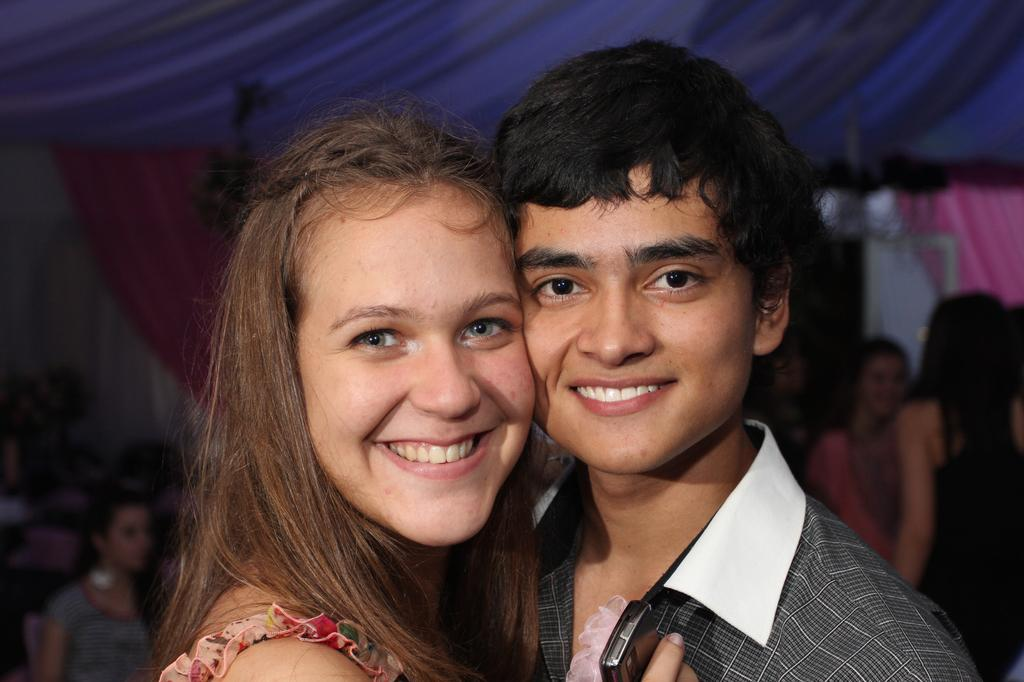How many people are present in the image? There are two people, a man and a woman, present in the image. What is the facial expression of the man and woman in the image? Both the man and woman are smiling in the image. What can be seen in the background of the image? There is a group of people, curtains, and some objects in the background of the image. Can you describe the object in the image? Unfortunately, the provided facts do not give a description of the object in the image. What is the texture of the waste in the image? There is no mention of waste in the image, and therefore no texture to describe. 